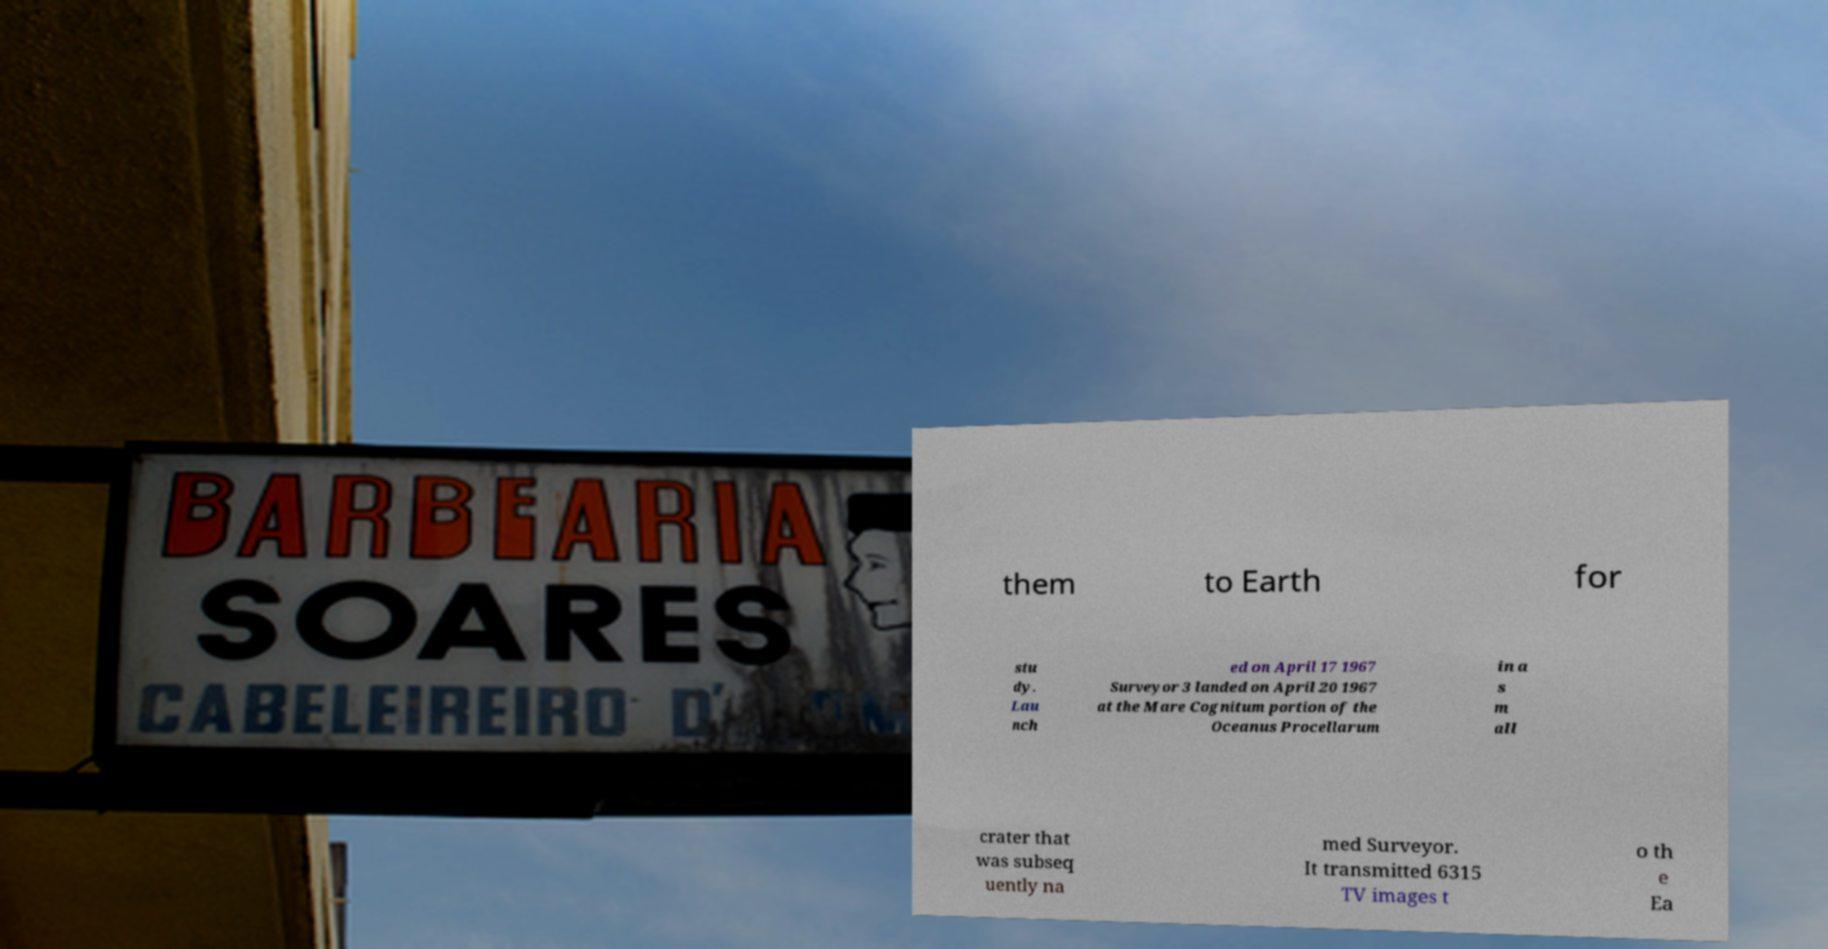Could you extract and type out the text from this image? them to Earth for stu dy. Lau nch ed on April 17 1967 Surveyor 3 landed on April 20 1967 at the Mare Cognitum portion of the Oceanus Procellarum in a s m all crater that was subseq uently na med Surveyor. It transmitted 6315 TV images t o th e Ea 